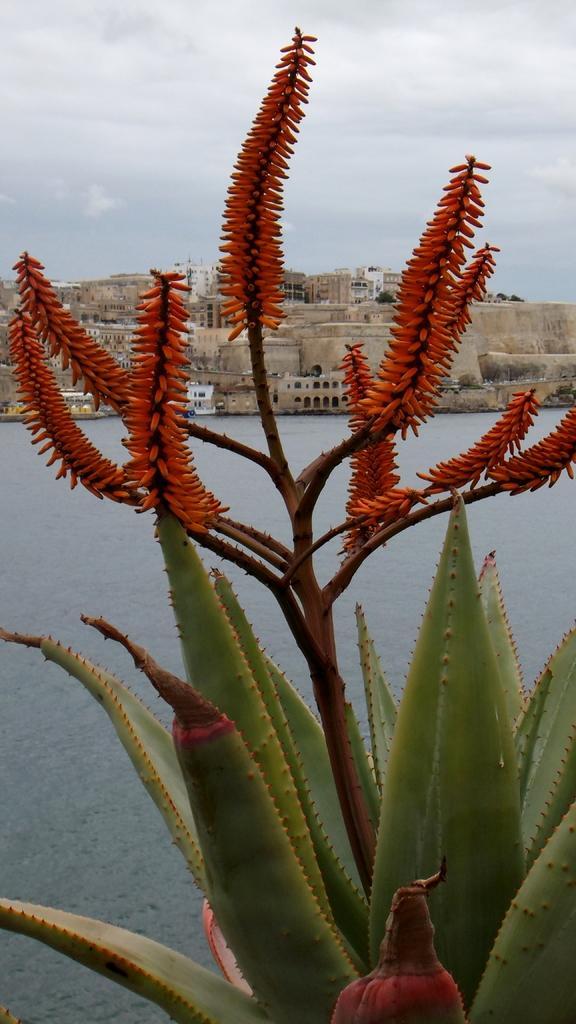Could you give a brief overview of what you see in this image? In this image I can see a plant which is green, brown and orange in color. In the background I can see the water, a boat with persons in it, few buildings and the sky. 